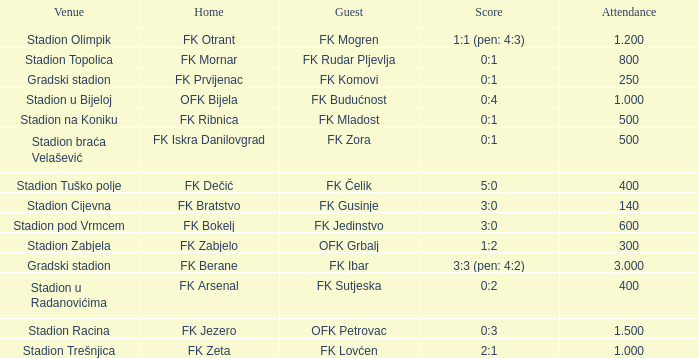What was the attendance of the game that had an away team of FK Mogren? 1.2. 